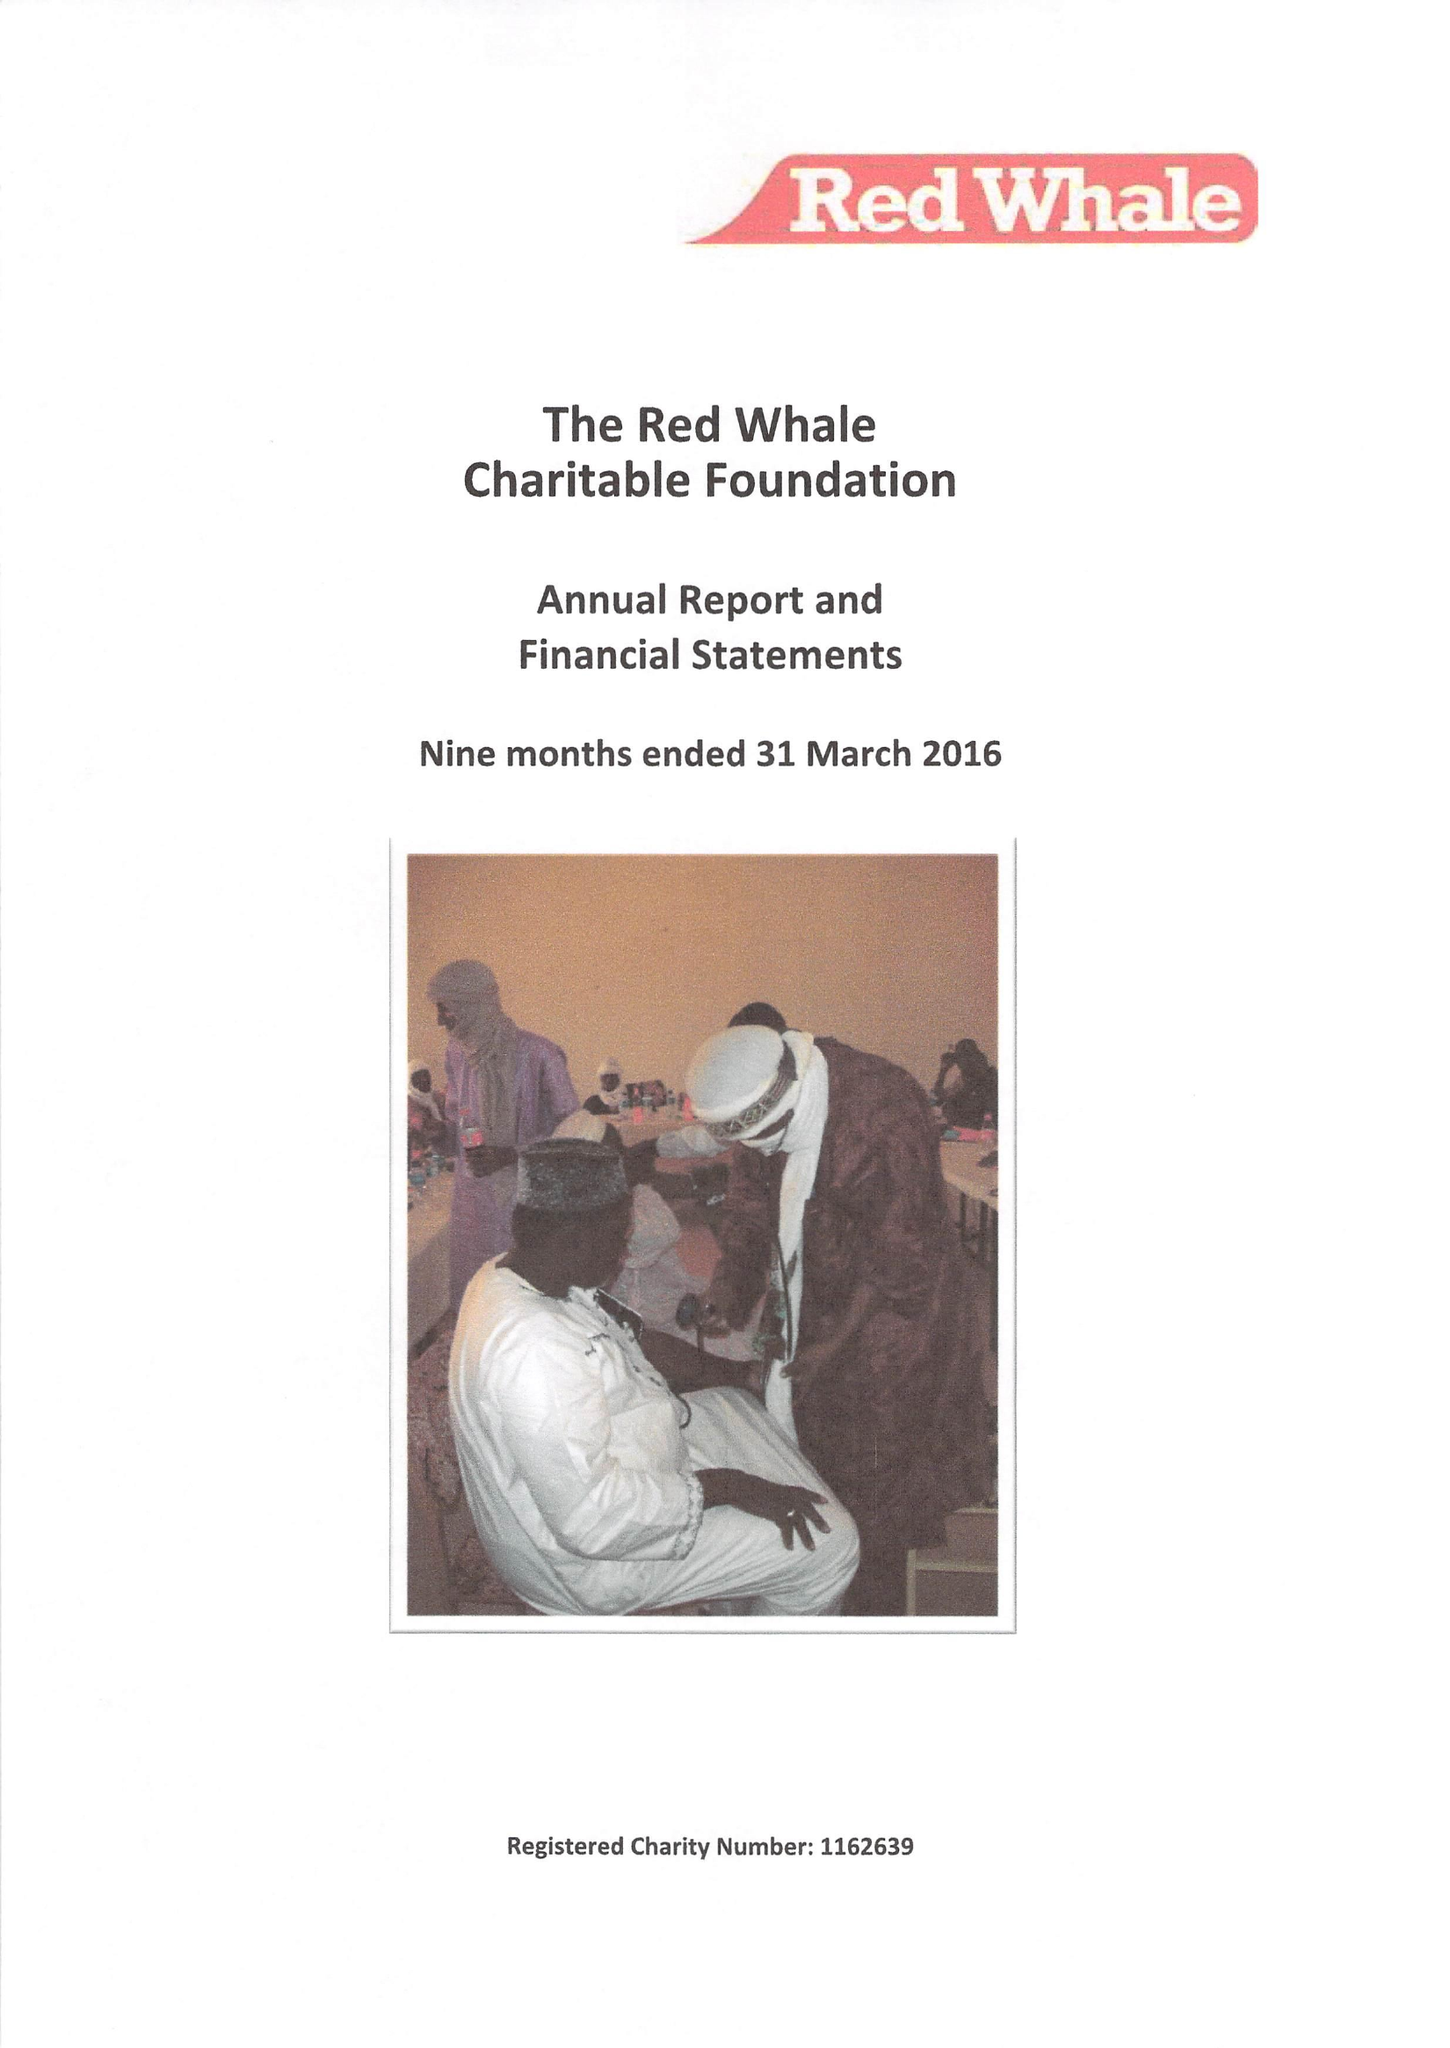What is the value for the address__postcode?
Answer the question using a single word or phrase. RG6 6BU 